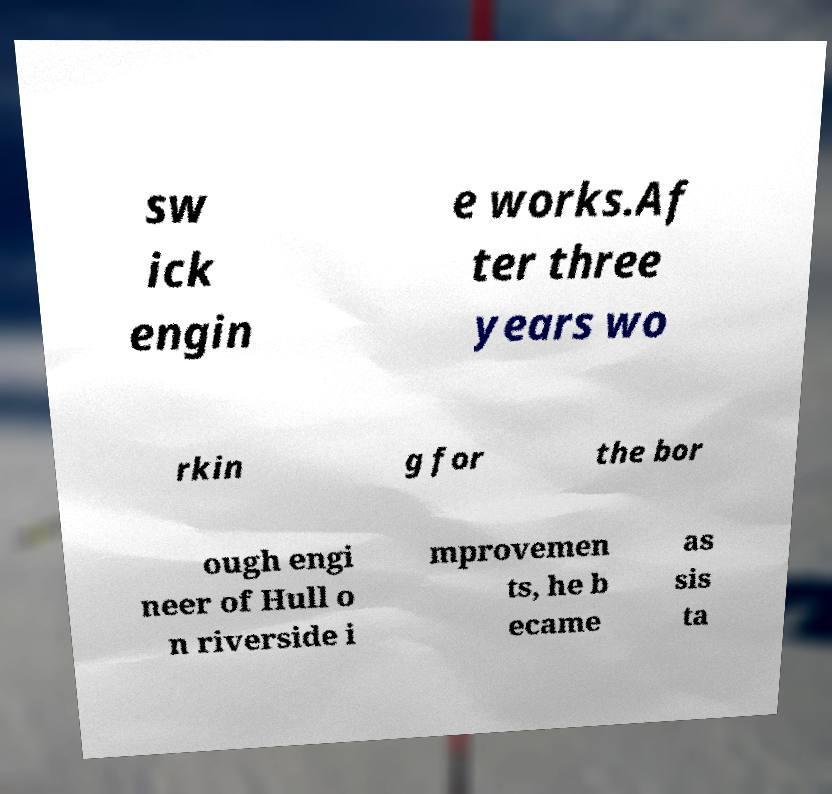Can you accurately transcribe the text from the provided image for me? sw ick engin e works.Af ter three years wo rkin g for the bor ough engi neer of Hull o n riverside i mprovemen ts, he b ecame as sis ta 